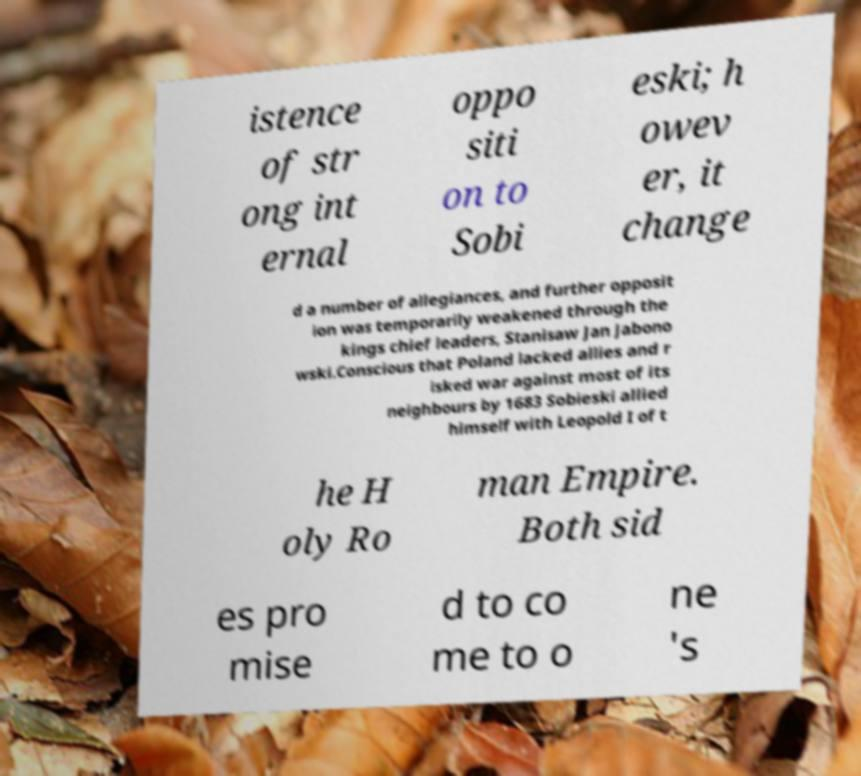I need the written content from this picture converted into text. Can you do that? istence of str ong int ernal oppo siti on to Sobi eski; h owev er, it change d a number of allegiances, and further opposit ion was temporarily weakened through the kings chief leaders, Stanisaw Jan Jabono wski.Conscious that Poland lacked allies and r isked war against most of its neighbours by 1683 Sobieski allied himself with Leopold I of t he H oly Ro man Empire. Both sid es pro mise d to co me to o ne 's 